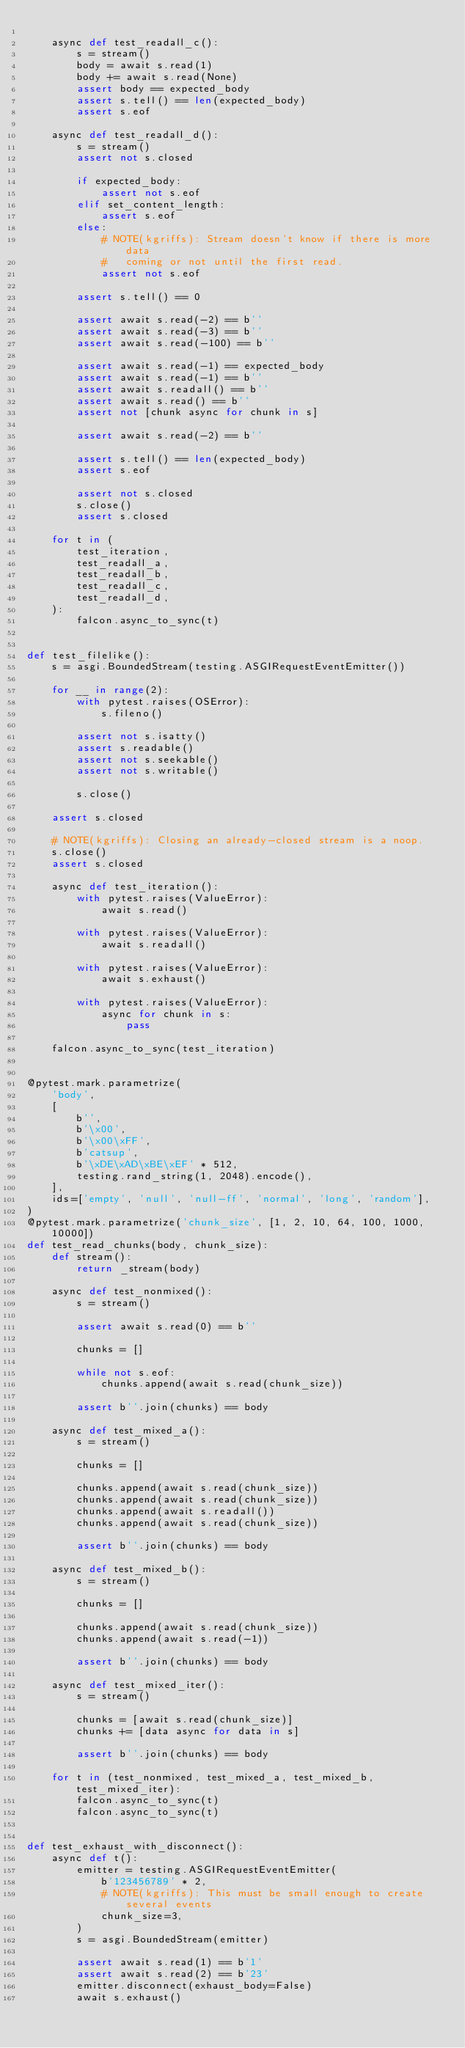<code> <loc_0><loc_0><loc_500><loc_500><_Python_>
    async def test_readall_c():
        s = stream()
        body = await s.read(1)
        body += await s.read(None)
        assert body == expected_body
        assert s.tell() == len(expected_body)
        assert s.eof

    async def test_readall_d():
        s = stream()
        assert not s.closed

        if expected_body:
            assert not s.eof
        elif set_content_length:
            assert s.eof
        else:
            # NOTE(kgriffs): Stream doesn't know if there is more data
            #   coming or not until the first read.
            assert not s.eof

        assert s.tell() == 0

        assert await s.read(-2) == b''
        assert await s.read(-3) == b''
        assert await s.read(-100) == b''

        assert await s.read(-1) == expected_body
        assert await s.read(-1) == b''
        assert await s.readall() == b''
        assert await s.read() == b''
        assert not [chunk async for chunk in s]

        assert await s.read(-2) == b''

        assert s.tell() == len(expected_body)
        assert s.eof

        assert not s.closed
        s.close()
        assert s.closed

    for t in (
        test_iteration,
        test_readall_a,
        test_readall_b,
        test_readall_c,
        test_readall_d,
    ):
        falcon.async_to_sync(t)


def test_filelike():
    s = asgi.BoundedStream(testing.ASGIRequestEventEmitter())

    for __ in range(2):
        with pytest.raises(OSError):
            s.fileno()

        assert not s.isatty()
        assert s.readable()
        assert not s.seekable()
        assert not s.writable()

        s.close()

    assert s.closed

    # NOTE(kgriffs): Closing an already-closed stream is a noop.
    s.close()
    assert s.closed

    async def test_iteration():
        with pytest.raises(ValueError):
            await s.read()

        with pytest.raises(ValueError):
            await s.readall()

        with pytest.raises(ValueError):
            await s.exhaust()

        with pytest.raises(ValueError):
            async for chunk in s:
                pass

    falcon.async_to_sync(test_iteration)


@pytest.mark.parametrize(
    'body',
    [
        b'',
        b'\x00',
        b'\x00\xFF',
        b'catsup',
        b'\xDE\xAD\xBE\xEF' * 512,
        testing.rand_string(1, 2048).encode(),
    ],
    ids=['empty', 'null', 'null-ff', 'normal', 'long', 'random'],
)
@pytest.mark.parametrize('chunk_size', [1, 2, 10, 64, 100, 1000, 10000])
def test_read_chunks(body, chunk_size):
    def stream():
        return _stream(body)

    async def test_nonmixed():
        s = stream()

        assert await s.read(0) == b''

        chunks = []

        while not s.eof:
            chunks.append(await s.read(chunk_size))

        assert b''.join(chunks) == body

    async def test_mixed_a():
        s = stream()

        chunks = []

        chunks.append(await s.read(chunk_size))
        chunks.append(await s.read(chunk_size))
        chunks.append(await s.readall())
        chunks.append(await s.read(chunk_size))

        assert b''.join(chunks) == body

    async def test_mixed_b():
        s = stream()

        chunks = []

        chunks.append(await s.read(chunk_size))
        chunks.append(await s.read(-1))

        assert b''.join(chunks) == body

    async def test_mixed_iter():
        s = stream()

        chunks = [await s.read(chunk_size)]
        chunks += [data async for data in s]

        assert b''.join(chunks) == body

    for t in (test_nonmixed, test_mixed_a, test_mixed_b, test_mixed_iter):
        falcon.async_to_sync(t)
        falcon.async_to_sync(t)


def test_exhaust_with_disconnect():
    async def t():
        emitter = testing.ASGIRequestEventEmitter(
            b'123456789' * 2,
            # NOTE(kgriffs): This must be small enough to create several events
            chunk_size=3,
        )
        s = asgi.BoundedStream(emitter)

        assert await s.read(1) == b'1'
        assert await s.read(2) == b'23'
        emitter.disconnect(exhaust_body=False)
        await s.exhaust()</code> 